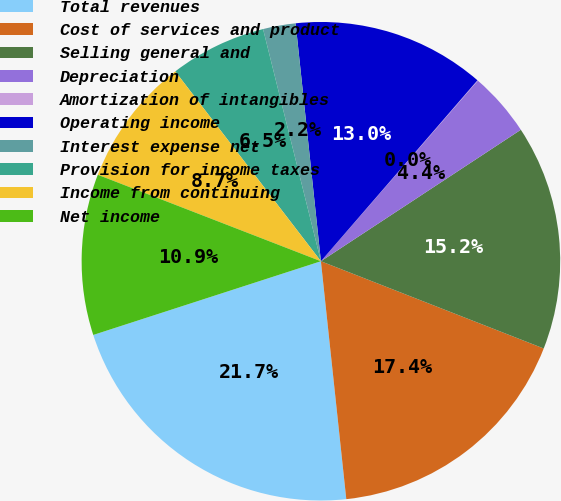<chart> <loc_0><loc_0><loc_500><loc_500><pie_chart><fcel>Total revenues<fcel>Cost of services and product<fcel>Selling general and<fcel>Depreciation<fcel>Amortization of intangibles<fcel>Operating income<fcel>Interest expense net<fcel>Provision for income taxes<fcel>Income from continuing<fcel>Net income<nl><fcel>21.71%<fcel>17.37%<fcel>15.2%<fcel>4.36%<fcel>0.03%<fcel>13.04%<fcel>2.2%<fcel>6.53%<fcel>8.7%<fcel>10.87%<nl></chart> 